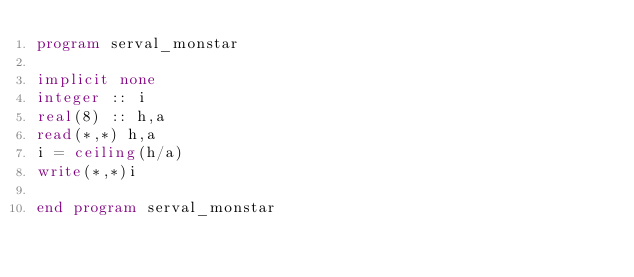<code> <loc_0><loc_0><loc_500><loc_500><_FORTRAN_>program serval_monstar

implicit none
integer :: i
real(8) :: h,a
read(*,*) h,a
i = ceiling(h/a)
write(*,*)i

end program serval_monstar</code> 